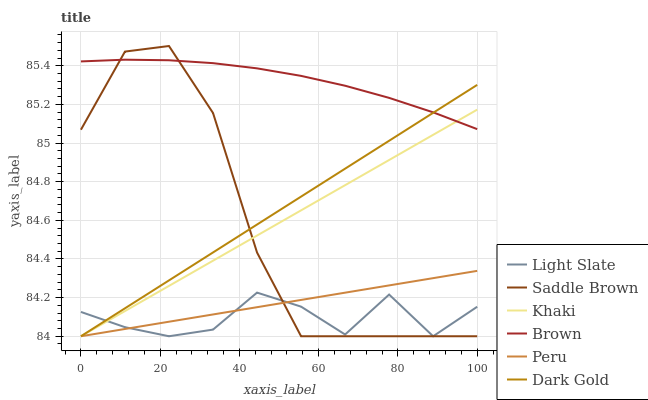Does Light Slate have the minimum area under the curve?
Answer yes or no. Yes. Does Brown have the maximum area under the curve?
Answer yes or no. Yes. Does Khaki have the minimum area under the curve?
Answer yes or no. No. Does Khaki have the maximum area under the curve?
Answer yes or no. No. Is Khaki the smoothest?
Answer yes or no. Yes. Is Saddle Brown the roughest?
Answer yes or no. Yes. Is Dark Gold the smoothest?
Answer yes or no. No. Is Dark Gold the roughest?
Answer yes or no. No. Does Saddle Brown have the highest value?
Answer yes or no. Yes. Does Khaki have the highest value?
Answer yes or no. No. Is Peru less than Brown?
Answer yes or no. Yes. Is Brown greater than Light Slate?
Answer yes or no. Yes. Does Brown intersect Khaki?
Answer yes or no. Yes. Is Brown less than Khaki?
Answer yes or no. No. Is Brown greater than Khaki?
Answer yes or no. No. Does Peru intersect Brown?
Answer yes or no. No. 